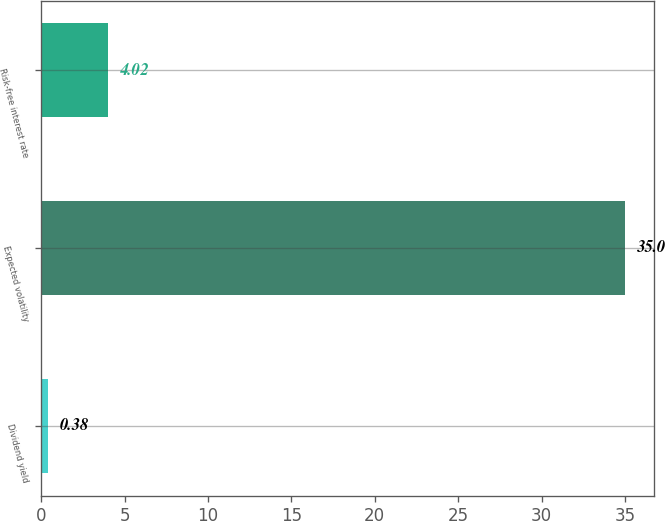<chart> <loc_0><loc_0><loc_500><loc_500><bar_chart><fcel>Dividend yield<fcel>Expected volatility<fcel>Risk-free interest rate<nl><fcel>0.38<fcel>35<fcel>4.02<nl></chart> 